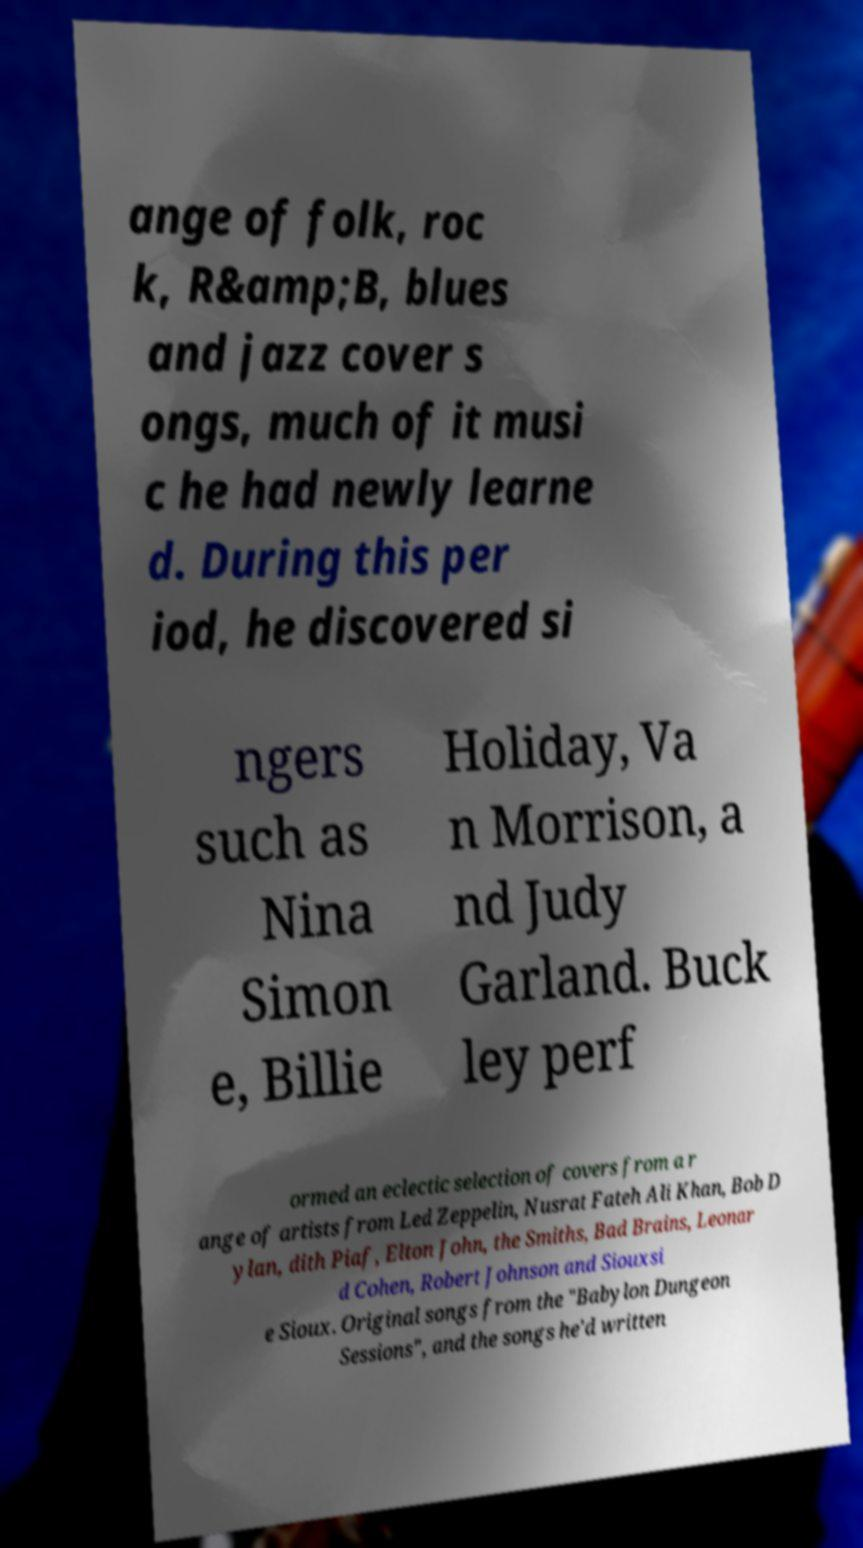For documentation purposes, I need the text within this image transcribed. Could you provide that? ange of folk, roc k, R&amp;B, blues and jazz cover s ongs, much of it musi c he had newly learne d. During this per iod, he discovered si ngers such as Nina Simon e, Billie Holiday, Va n Morrison, a nd Judy Garland. Buck ley perf ormed an eclectic selection of covers from a r ange of artists from Led Zeppelin, Nusrat Fateh Ali Khan, Bob D ylan, dith Piaf, Elton John, the Smiths, Bad Brains, Leonar d Cohen, Robert Johnson and Siouxsi e Sioux. Original songs from the "Babylon Dungeon Sessions", and the songs he'd written 